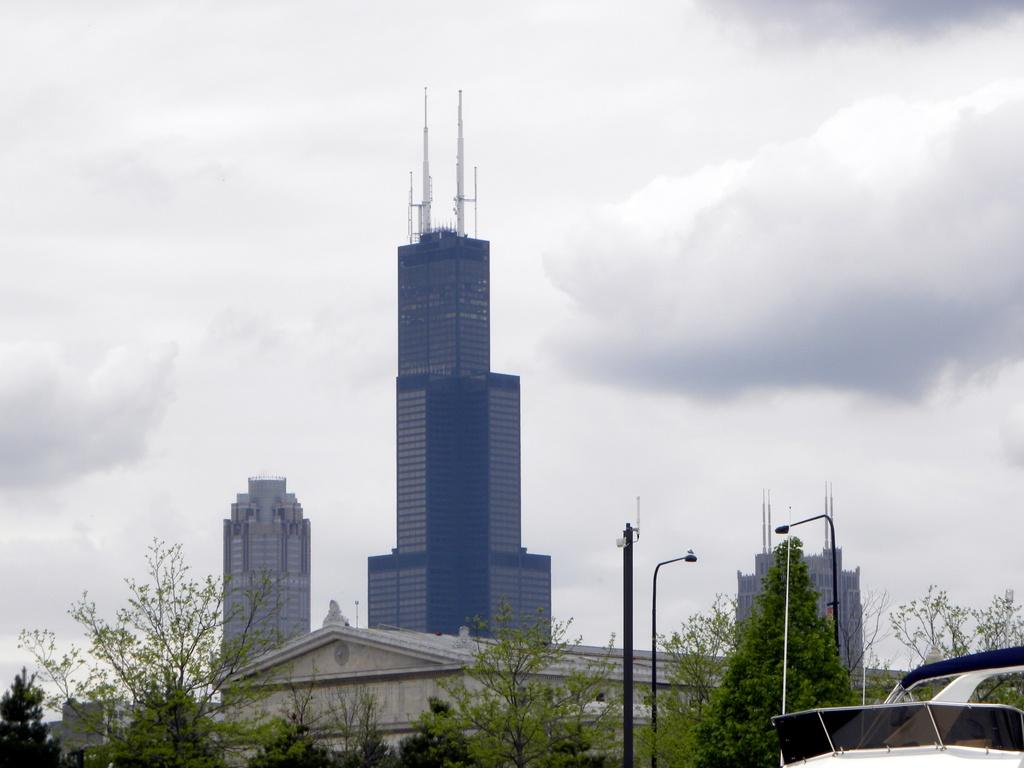What type of natural vegetation can be seen in the image? There is a group of trees in the image. What type of man-made structures are present in the image? There is a group of buildings with roofs in the image. What type of lighting is present in the image? There are light poles in the image. What is visible in the background of the image? The sky is visible in the background of the image. What is the weather condition suggested by the sky in the image? The sky appears to be cloudy, suggesting a potentially overcast or rainy day. Can you tell me how many cherries are in the jar in the image? There is no jar or cherries present in the image. What type of unit is being measured by the group of trees in the image? There is no unit being measured by the group of trees in the image; they are simply a natural feature in the scene. 